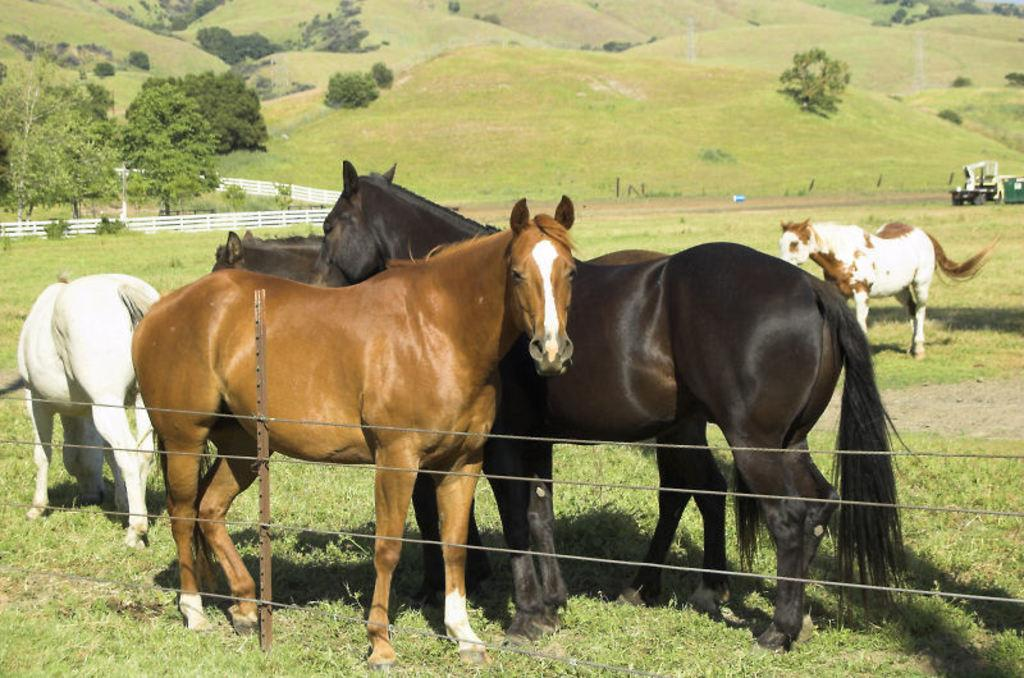What animals can be seen in the image? There are horses in the image. What type of vegetation is present in the image? There are trees in the image. What geographical features can be seen in the image? There are hills in the image. What type of ground cover is visible in the image? There is grass in the image. What man-made object can be seen in the image? There is a vehicle in the image. What type of shop can be seen on the roof in the image? There is no shop or roof present in the image; it features horses, trees, hills, grass, and a vehicle. 